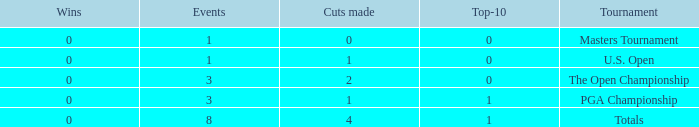For events with under 3 times played and fewer than 1 cut made, what is the total number of top-10 finishes? 1.0. 